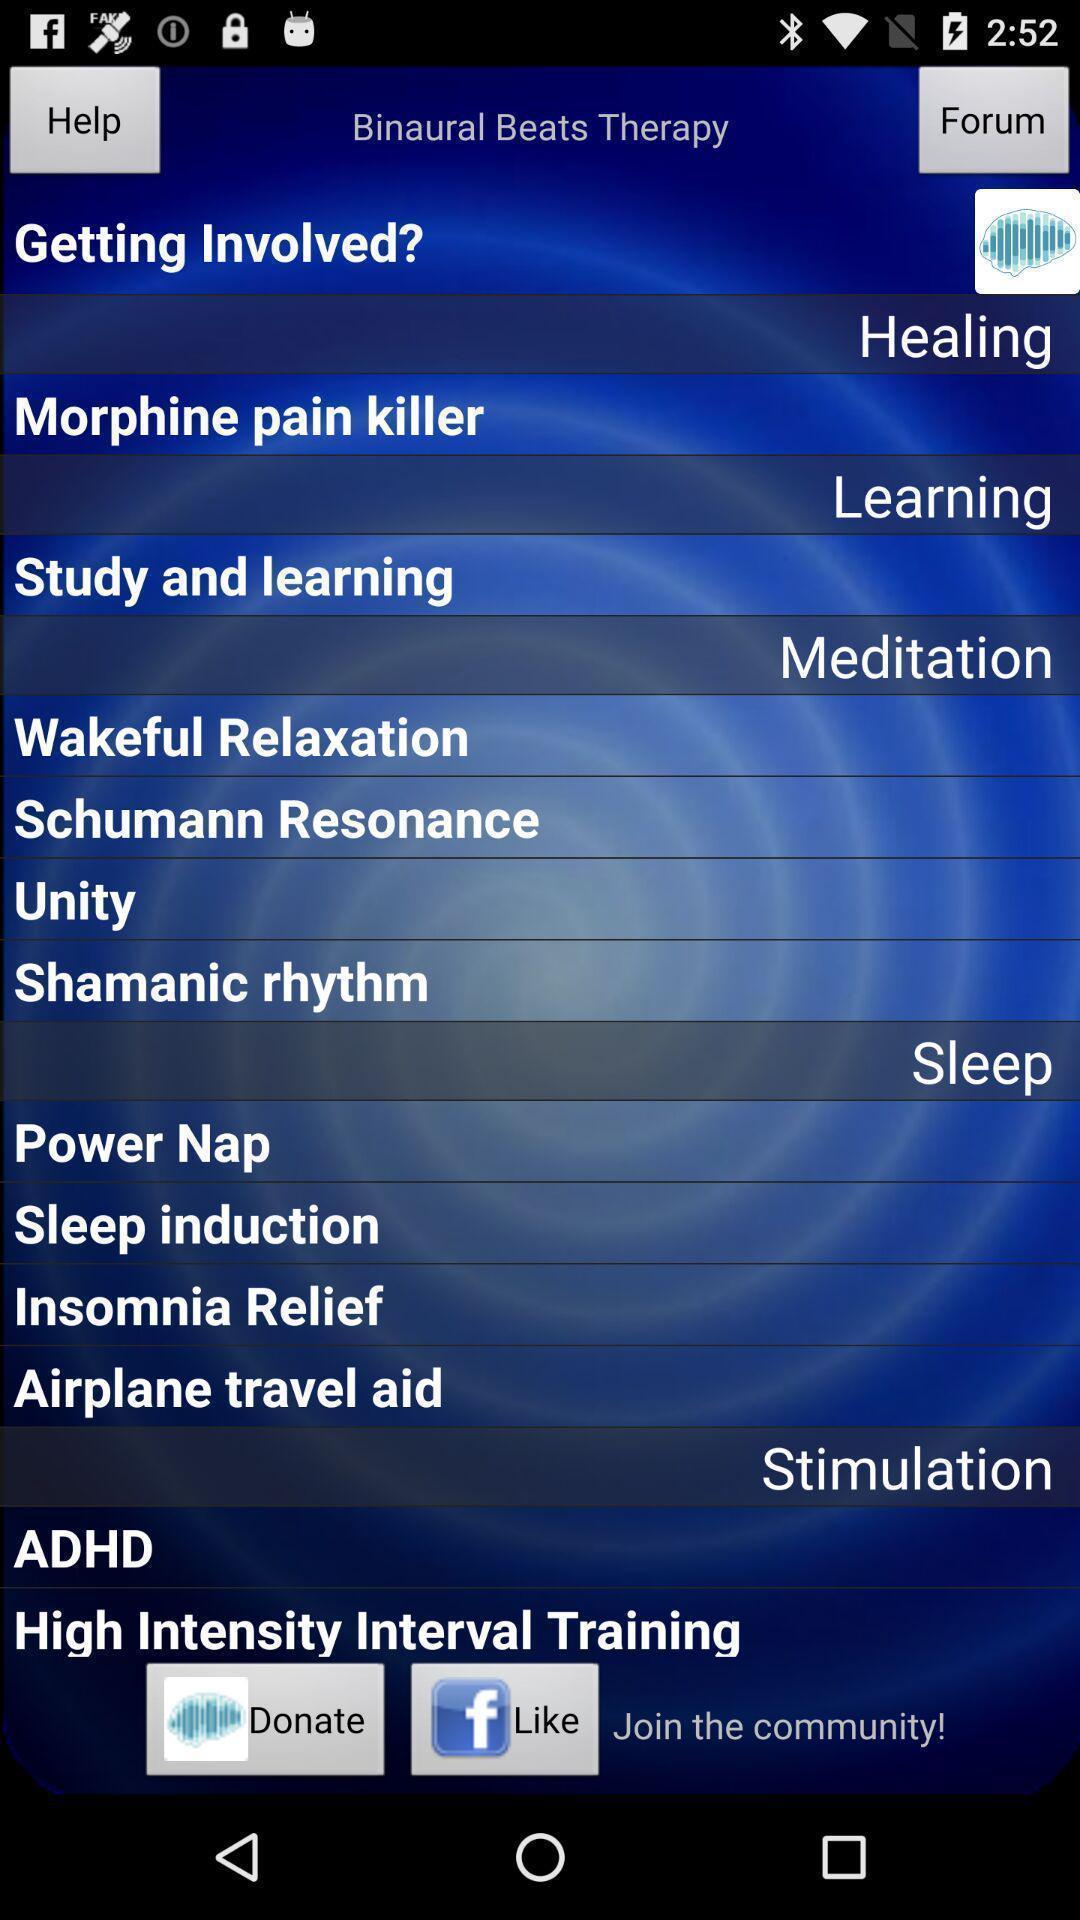Explain what's happening in this screen capture. Screen showing learning page. 